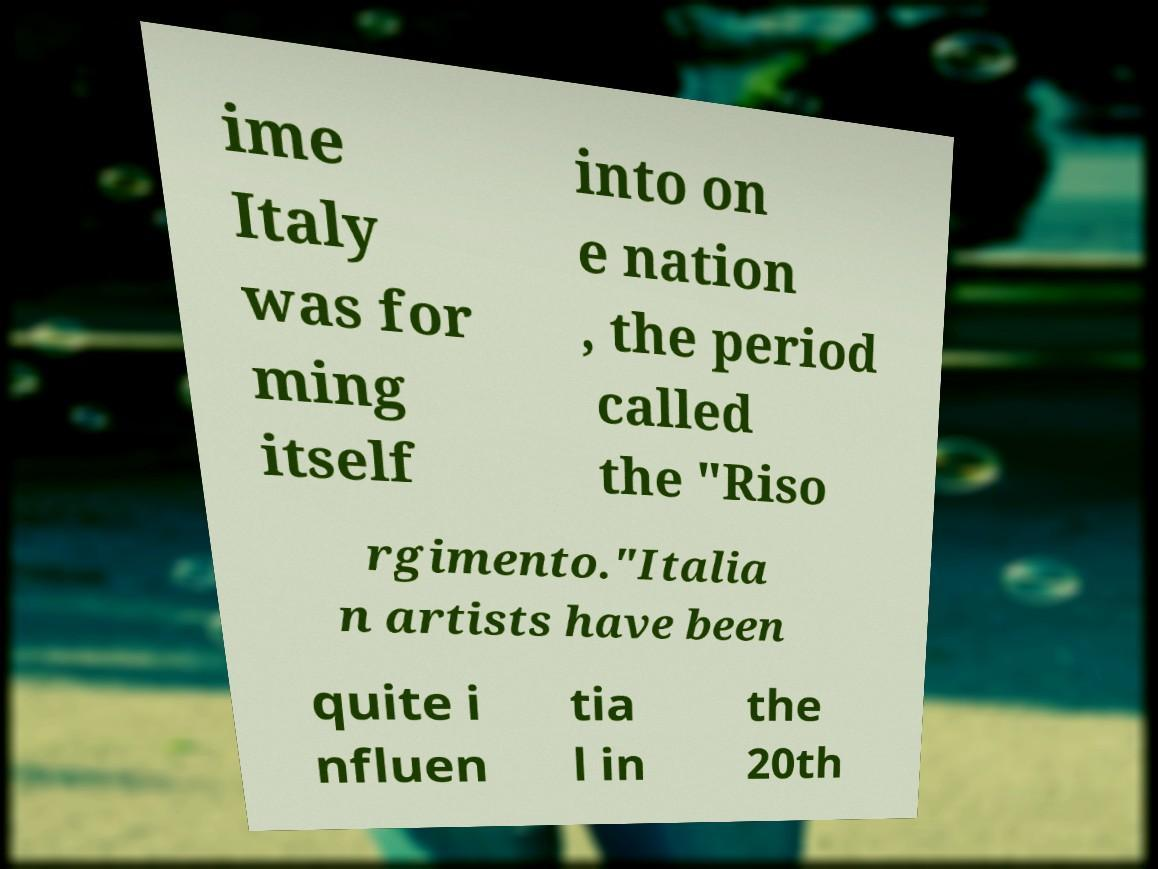Could you extract and type out the text from this image? ime Italy was for ming itself into on e nation , the period called the "Riso rgimento."Italia n artists have been quite i nfluen tia l in the 20th 